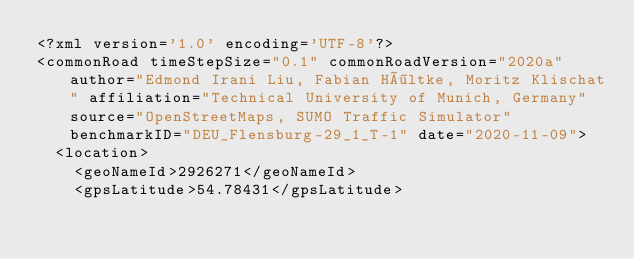<code> <loc_0><loc_0><loc_500><loc_500><_XML_><?xml version='1.0' encoding='UTF-8'?>
<commonRoad timeStepSize="0.1" commonRoadVersion="2020a" author="Edmond Irani Liu, Fabian Höltke, Moritz Klischat" affiliation="Technical University of Munich, Germany" source="OpenStreetMaps, SUMO Traffic Simulator" benchmarkID="DEU_Flensburg-29_1_T-1" date="2020-11-09">
  <location>
    <geoNameId>2926271</geoNameId>
    <gpsLatitude>54.78431</gpsLatitude></code> 